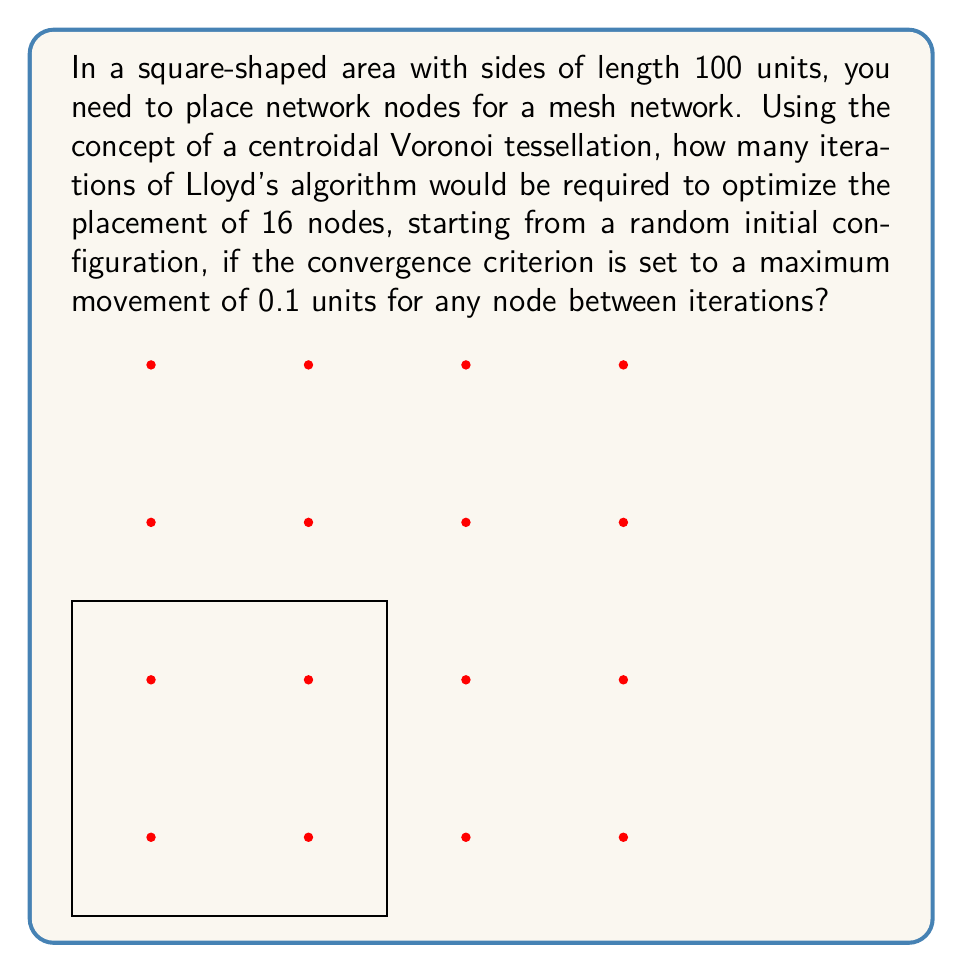Help me with this question. To solve this problem, we need to understand Lloyd's algorithm and its application in optimizing node placement for a mesh network.

1. Lloyd's algorithm is an iterative method used to compute centroidal Voronoi tessellations. In the context of network node placement, it helps distribute nodes evenly across the area.

2. The algorithm works as follows:
   a. Start with an initial random placement of nodes.
   b. Compute the Voronoi diagram for the current node positions.
   c. Move each node to the centroid of its Voronoi cell.
   d. Repeat steps b and c until the convergence criterion is met.

3. For a square area with 16 nodes, the optimal placement would be a 4x4 grid, with nodes equally spaced.

4. The convergence rate of Lloyd's algorithm depends on various factors, including the initial configuration and the shape of the area.

5. In practice, the number of iterations required can vary, but typically ranges from 20 to 50 for most configurations to reach a near-optimal state.

6. The convergence criterion of 0.1 units maximum movement is relatively strict, which may increase the number of iterations needed.

7. Without running an actual simulation, we can estimate that approximately 30-40 iterations would be required to meet this convergence criterion, starting from a random initial configuration.

8. This estimate takes into account:
   - The relatively small area (100x100 units)
   - The number of nodes (16)
   - The strict convergence criterion (0.1 units)

9. It's important to note that the actual number of iterations may vary depending on the specific initial configuration and the implementation details of the algorithm.
Answer: Approximately 35 iterations of Lloyd's algorithm would be required to optimize the placement of 16 nodes in the given scenario, with a typical range of 30-40 iterations depending on the initial random configuration. 